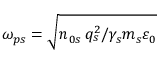Convert formula to latex. <formula><loc_0><loc_0><loc_500><loc_500>\omega _ { p s } = \sqrt { n _ { 0 s } \, q _ { s } ^ { 2 } / \gamma _ { s } m _ { s } \varepsilon _ { 0 } }</formula> 